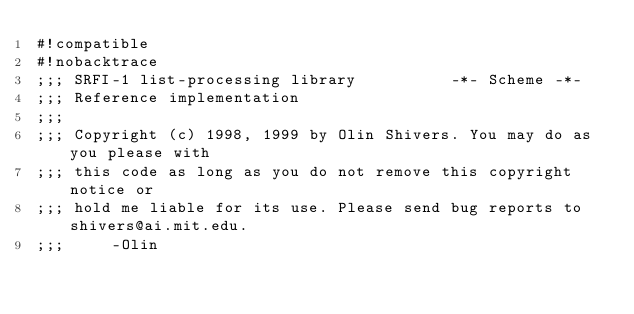Convert code to text. <code><loc_0><loc_0><loc_500><loc_500><_Scheme_>#!compatible
#!nobacktrace
;;; SRFI-1 list-processing library          -*- Scheme -*-
;;; Reference implementation
;;;
;;; Copyright (c) 1998, 1999 by Olin Shivers. You may do as you please with
;;; this code as long as you do not remove this copyright notice or
;;; hold me liable for its use. Please send bug reports to shivers@ai.mit.edu.
;;;     -Olin
</code> 